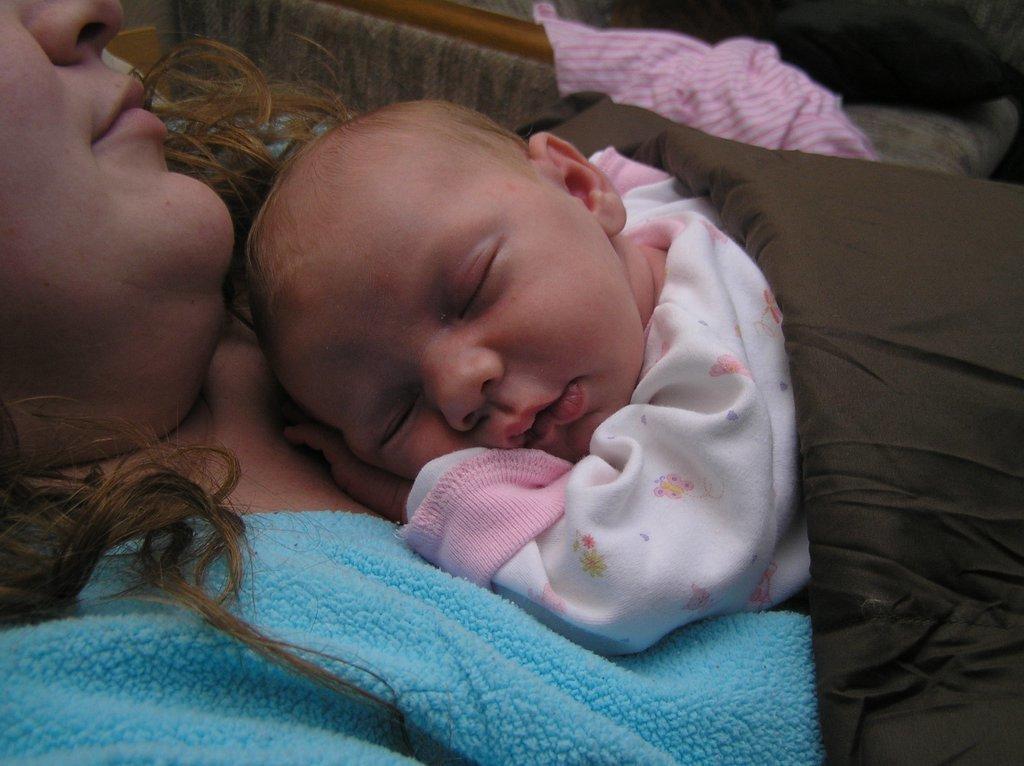Could you give a brief overview of what you see in this image? In this image I can see two persons and they are sleeping. The person at right wearing white dress and the person at left wearing blue color dress. I can also see a brown color blanket. 